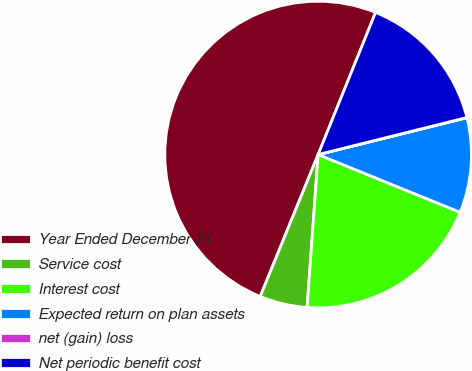<chart> <loc_0><loc_0><loc_500><loc_500><pie_chart><fcel>Year Ended December 31<fcel>Service cost<fcel>Interest cost<fcel>Expected return on plan assets<fcel>net (gain) loss<fcel>Net periodic benefit cost<nl><fcel>49.95%<fcel>5.02%<fcel>20.0%<fcel>10.01%<fcel>0.02%<fcel>15.0%<nl></chart> 